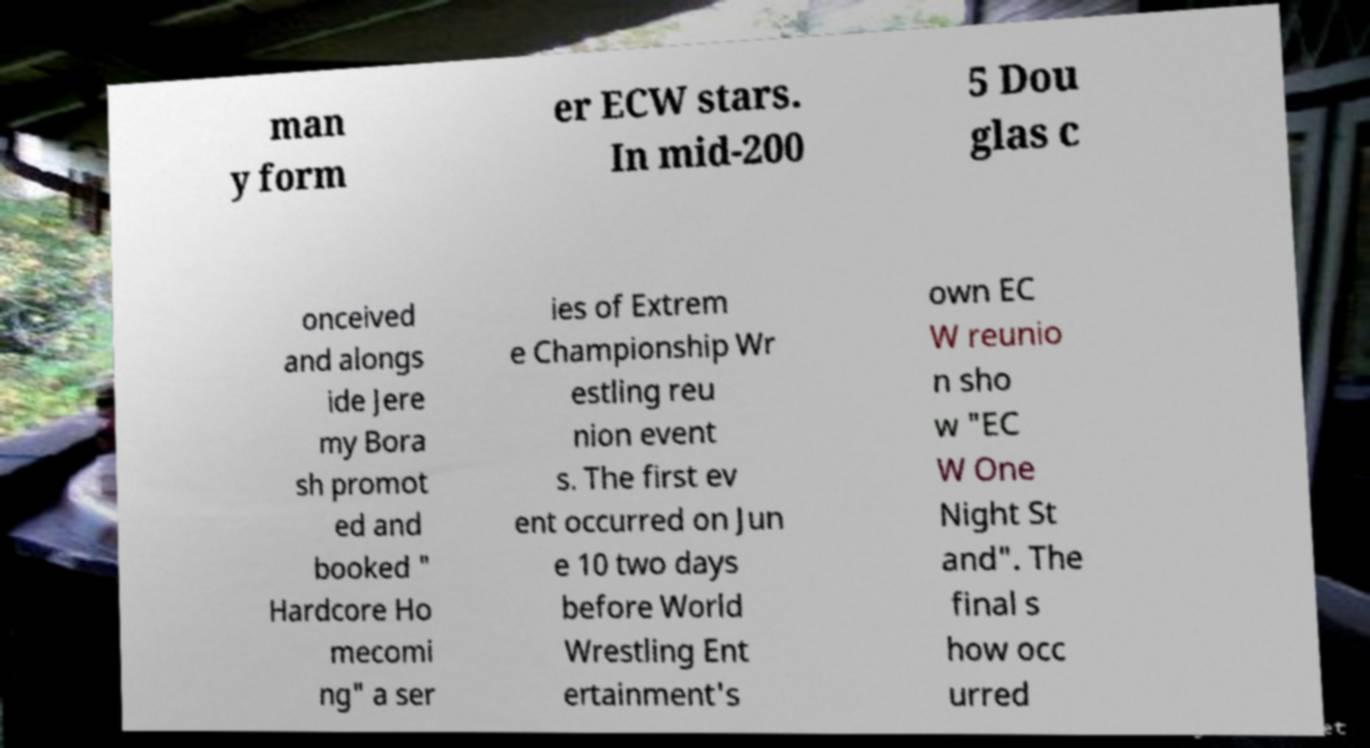Can you accurately transcribe the text from the provided image for me? man y form er ECW stars. In mid-200 5 Dou glas c onceived and alongs ide Jere my Bora sh promot ed and booked " Hardcore Ho mecomi ng" a ser ies of Extrem e Championship Wr estling reu nion event s. The first ev ent occurred on Jun e 10 two days before World Wrestling Ent ertainment's own EC W reunio n sho w "EC W One Night St and". The final s how occ urred 